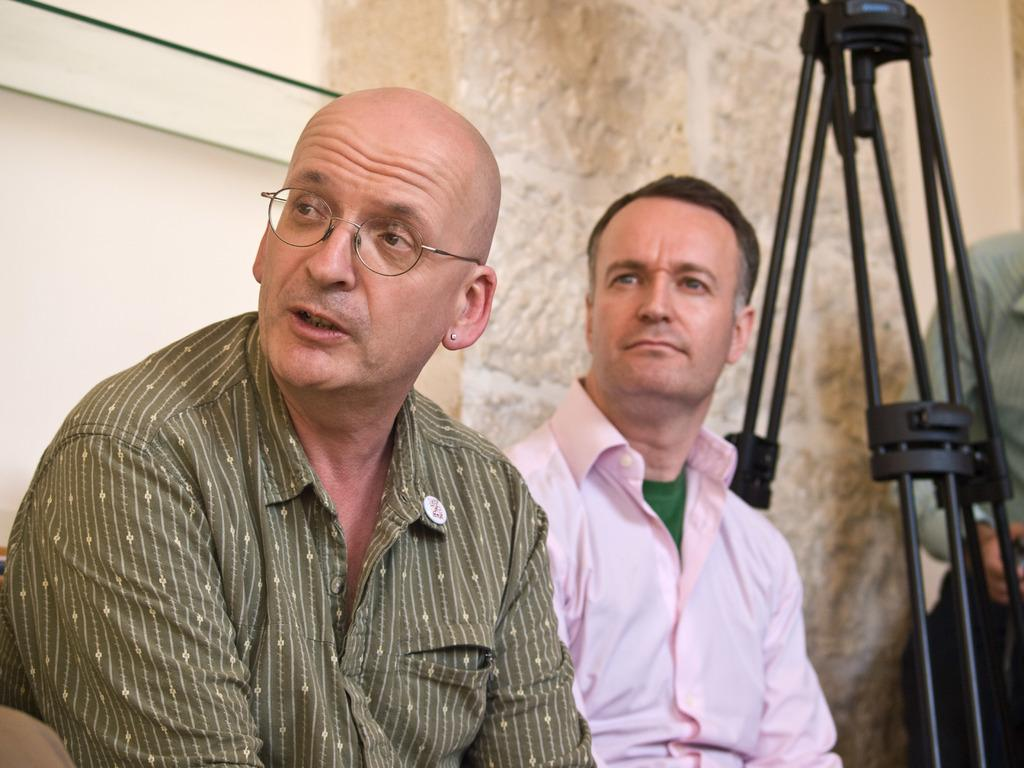What are the people in the image doing? The people in the image are sitting on chairs. What can be seen in the background of the image? There is a wall and a stand in the background of the image. Is there anyone near the stand? Yes, there is a person standing near the stand. How many pins are attached to the cobweb in the image? There is no cobweb or pins present in the image. 